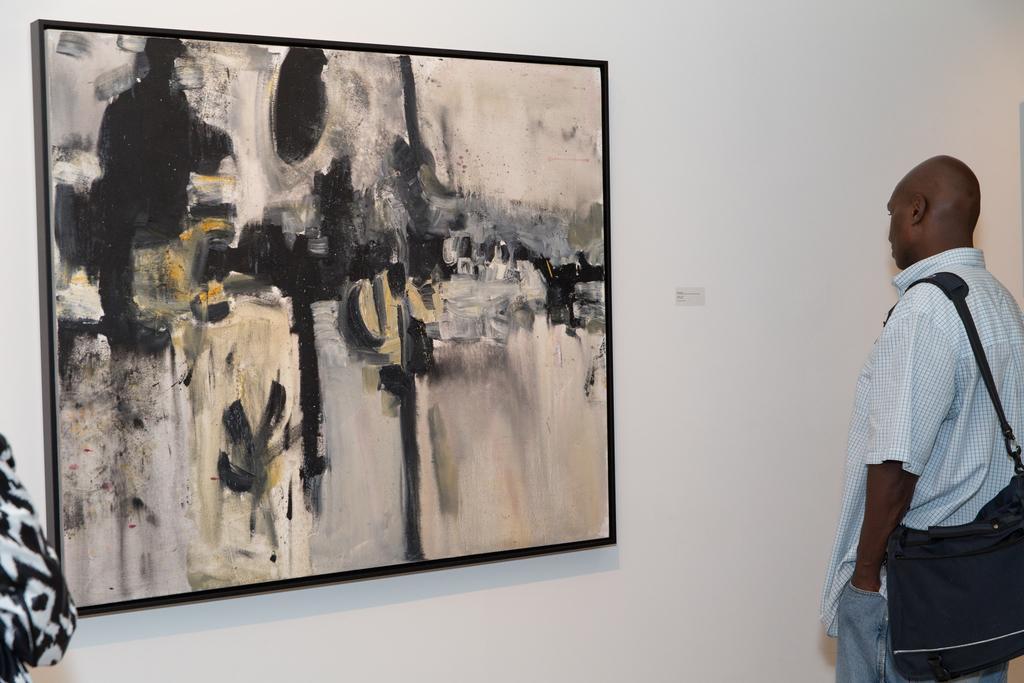How would you summarize this image in a sentence or two? In this image, we can see a person standing and wearing a bag and there is an other person and we can see a frame on the wall. 